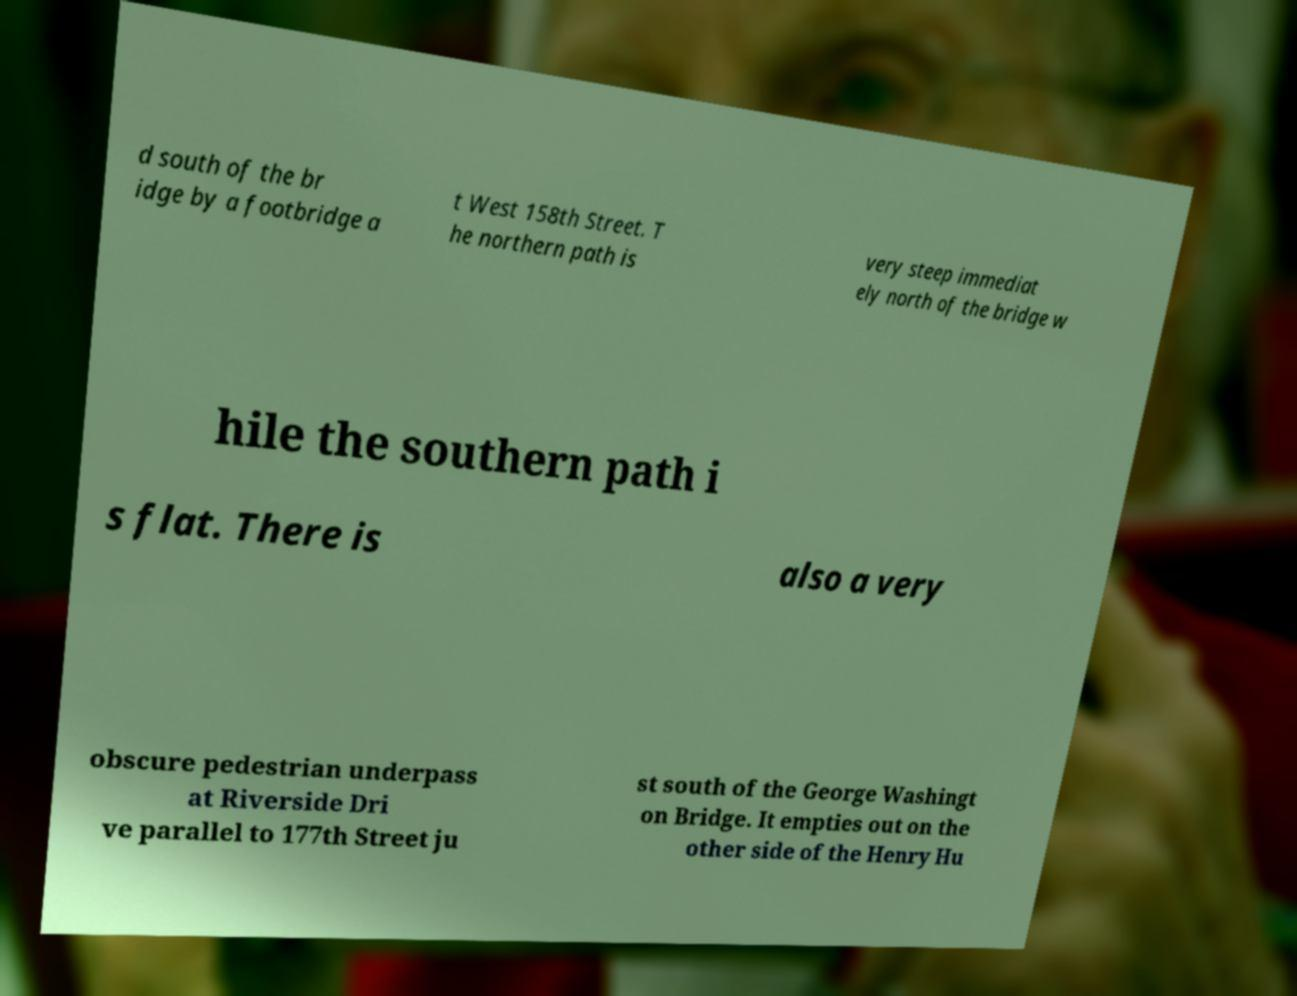I need the written content from this picture converted into text. Can you do that? d south of the br idge by a footbridge a t West 158th Street. T he northern path is very steep immediat ely north of the bridge w hile the southern path i s flat. There is also a very obscure pedestrian underpass at Riverside Dri ve parallel to 177th Street ju st south of the George Washingt on Bridge. It empties out on the other side of the Henry Hu 